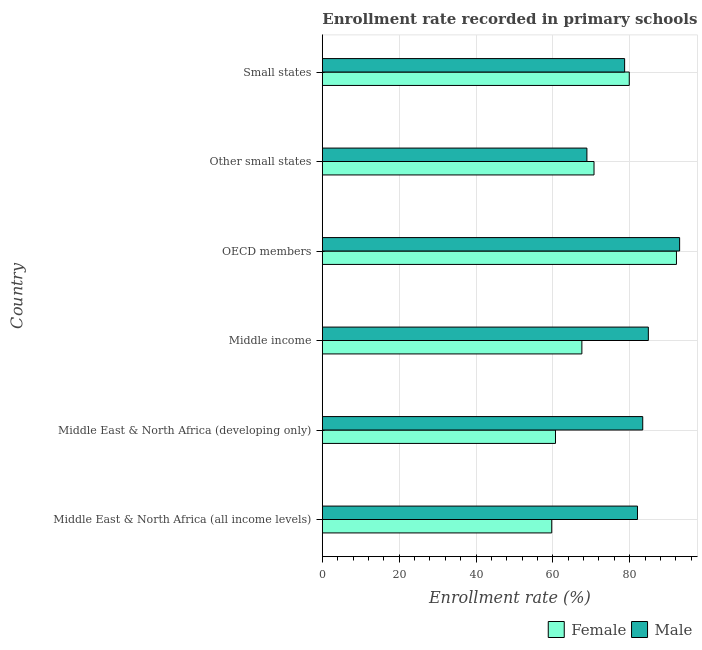How many different coloured bars are there?
Keep it short and to the point. 2. How many bars are there on the 1st tick from the bottom?
Your response must be concise. 2. What is the label of the 3rd group of bars from the top?
Give a very brief answer. OECD members. What is the enrollment rate of male students in Small states?
Your answer should be very brief. 78.69. Across all countries, what is the maximum enrollment rate of female students?
Your answer should be compact. 92.18. Across all countries, what is the minimum enrollment rate of female students?
Give a very brief answer. 59.71. In which country was the enrollment rate of male students maximum?
Give a very brief answer. OECD members. In which country was the enrollment rate of female students minimum?
Provide a succinct answer. Middle East & North Africa (all income levels). What is the total enrollment rate of female students in the graph?
Ensure brevity in your answer.  430.75. What is the difference between the enrollment rate of female students in Middle East & North Africa (all income levels) and that in Middle income?
Make the answer very short. -7.84. What is the difference between the enrollment rate of female students in Small states and the enrollment rate of male students in OECD members?
Make the answer very short. -13.11. What is the average enrollment rate of female students per country?
Provide a succinct answer. 71.79. What is the difference between the enrollment rate of male students and enrollment rate of female students in Middle income?
Your answer should be compact. 17.3. What is the ratio of the enrollment rate of male students in Middle East & North Africa (all income levels) to that in Small states?
Offer a very short reply. 1.04. What is the difference between the highest and the second highest enrollment rate of female students?
Provide a succinct answer. 12.28. What is the difference between the highest and the lowest enrollment rate of female students?
Your response must be concise. 32.46. In how many countries, is the enrollment rate of female students greater than the average enrollment rate of female students taken over all countries?
Your answer should be very brief. 2. Is the sum of the enrollment rate of female students in Middle East & North Africa (all income levels) and Middle East & North Africa (developing only) greater than the maximum enrollment rate of male students across all countries?
Ensure brevity in your answer.  Yes. What does the 1st bar from the top in Other small states represents?
Offer a very short reply. Male. How many countries are there in the graph?
Ensure brevity in your answer.  6. Does the graph contain grids?
Offer a very short reply. Yes. How many legend labels are there?
Provide a succinct answer. 2. What is the title of the graph?
Keep it short and to the point. Enrollment rate recorded in primary schools in year 1979. Does "International Visitors" appear as one of the legend labels in the graph?
Keep it short and to the point. No. What is the label or title of the X-axis?
Provide a succinct answer. Enrollment rate (%). What is the label or title of the Y-axis?
Give a very brief answer. Country. What is the Enrollment rate (%) of Female in Middle East & North Africa (all income levels)?
Provide a succinct answer. 59.71. What is the Enrollment rate (%) in Male in Middle East & North Africa (all income levels)?
Offer a terse response. 82.03. What is the Enrollment rate (%) in Female in Middle East & North Africa (developing only)?
Make the answer very short. 60.69. What is the Enrollment rate (%) in Male in Middle East & North Africa (developing only)?
Your answer should be very brief. 83.4. What is the Enrollment rate (%) of Female in Middle income?
Provide a succinct answer. 67.56. What is the Enrollment rate (%) in Male in Middle income?
Make the answer very short. 84.86. What is the Enrollment rate (%) of Female in OECD members?
Offer a very short reply. 92.18. What is the Enrollment rate (%) of Male in OECD members?
Your answer should be very brief. 93. What is the Enrollment rate (%) in Female in Other small states?
Offer a terse response. 70.72. What is the Enrollment rate (%) of Male in Other small states?
Your response must be concise. 68.87. What is the Enrollment rate (%) in Female in Small states?
Your answer should be compact. 79.89. What is the Enrollment rate (%) of Male in Small states?
Provide a short and direct response. 78.69. Across all countries, what is the maximum Enrollment rate (%) of Female?
Keep it short and to the point. 92.18. Across all countries, what is the maximum Enrollment rate (%) of Male?
Provide a short and direct response. 93. Across all countries, what is the minimum Enrollment rate (%) of Female?
Make the answer very short. 59.71. Across all countries, what is the minimum Enrollment rate (%) in Male?
Your response must be concise. 68.87. What is the total Enrollment rate (%) of Female in the graph?
Your response must be concise. 430.75. What is the total Enrollment rate (%) in Male in the graph?
Make the answer very short. 490.85. What is the difference between the Enrollment rate (%) of Female in Middle East & North Africa (all income levels) and that in Middle East & North Africa (developing only)?
Ensure brevity in your answer.  -0.97. What is the difference between the Enrollment rate (%) in Male in Middle East & North Africa (all income levels) and that in Middle East & North Africa (developing only)?
Offer a very short reply. -1.37. What is the difference between the Enrollment rate (%) of Female in Middle East & North Africa (all income levels) and that in Middle income?
Offer a terse response. -7.84. What is the difference between the Enrollment rate (%) in Male in Middle East & North Africa (all income levels) and that in Middle income?
Provide a succinct answer. -2.83. What is the difference between the Enrollment rate (%) of Female in Middle East & North Africa (all income levels) and that in OECD members?
Your answer should be very brief. -32.46. What is the difference between the Enrollment rate (%) of Male in Middle East & North Africa (all income levels) and that in OECD members?
Make the answer very short. -10.97. What is the difference between the Enrollment rate (%) of Female in Middle East & North Africa (all income levels) and that in Other small states?
Provide a succinct answer. -11.01. What is the difference between the Enrollment rate (%) in Male in Middle East & North Africa (all income levels) and that in Other small states?
Keep it short and to the point. 13.16. What is the difference between the Enrollment rate (%) of Female in Middle East & North Africa (all income levels) and that in Small states?
Your answer should be compact. -20.18. What is the difference between the Enrollment rate (%) in Male in Middle East & North Africa (all income levels) and that in Small states?
Offer a very short reply. 3.35. What is the difference between the Enrollment rate (%) in Female in Middle East & North Africa (developing only) and that in Middle income?
Offer a very short reply. -6.87. What is the difference between the Enrollment rate (%) of Male in Middle East & North Africa (developing only) and that in Middle income?
Offer a terse response. -1.46. What is the difference between the Enrollment rate (%) of Female in Middle East & North Africa (developing only) and that in OECD members?
Give a very brief answer. -31.49. What is the difference between the Enrollment rate (%) of Male in Middle East & North Africa (developing only) and that in OECD members?
Your response must be concise. -9.6. What is the difference between the Enrollment rate (%) in Female in Middle East & North Africa (developing only) and that in Other small states?
Offer a terse response. -10.03. What is the difference between the Enrollment rate (%) in Male in Middle East & North Africa (developing only) and that in Other small states?
Provide a short and direct response. 14.53. What is the difference between the Enrollment rate (%) in Female in Middle East & North Africa (developing only) and that in Small states?
Your response must be concise. -19.21. What is the difference between the Enrollment rate (%) of Male in Middle East & North Africa (developing only) and that in Small states?
Ensure brevity in your answer.  4.71. What is the difference between the Enrollment rate (%) in Female in Middle income and that in OECD members?
Ensure brevity in your answer.  -24.62. What is the difference between the Enrollment rate (%) of Male in Middle income and that in OECD members?
Offer a very short reply. -8.14. What is the difference between the Enrollment rate (%) in Female in Middle income and that in Other small states?
Provide a succinct answer. -3.16. What is the difference between the Enrollment rate (%) of Male in Middle income and that in Other small states?
Keep it short and to the point. 15.99. What is the difference between the Enrollment rate (%) of Female in Middle income and that in Small states?
Your answer should be compact. -12.34. What is the difference between the Enrollment rate (%) in Male in Middle income and that in Small states?
Provide a short and direct response. 6.17. What is the difference between the Enrollment rate (%) in Female in OECD members and that in Other small states?
Make the answer very short. 21.46. What is the difference between the Enrollment rate (%) of Male in OECD members and that in Other small states?
Offer a very short reply. 24.13. What is the difference between the Enrollment rate (%) in Female in OECD members and that in Small states?
Provide a short and direct response. 12.28. What is the difference between the Enrollment rate (%) of Male in OECD members and that in Small states?
Keep it short and to the point. 14.32. What is the difference between the Enrollment rate (%) of Female in Other small states and that in Small states?
Offer a terse response. -9.18. What is the difference between the Enrollment rate (%) in Male in Other small states and that in Small states?
Ensure brevity in your answer.  -9.82. What is the difference between the Enrollment rate (%) of Female in Middle East & North Africa (all income levels) and the Enrollment rate (%) of Male in Middle East & North Africa (developing only)?
Make the answer very short. -23.69. What is the difference between the Enrollment rate (%) of Female in Middle East & North Africa (all income levels) and the Enrollment rate (%) of Male in Middle income?
Your answer should be compact. -25.15. What is the difference between the Enrollment rate (%) of Female in Middle East & North Africa (all income levels) and the Enrollment rate (%) of Male in OECD members?
Your answer should be very brief. -33.29. What is the difference between the Enrollment rate (%) of Female in Middle East & North Africa (all income levels) and the Enrollment rate (%) of Male in Other small states?
Offer a terse response. -9.16. What is the difference between the Enrollment rate (%) in Female in Middle East & North Africa (all income levels) and the Enrollment rate (%) in Male in Small states?
Provide a short and direct response. -18.97. What is the difference between the Enrollment rate (%) of Female in Middle East & North Africa (developing only) and the Enrollment rate (%) of Male in Middle income?
Provide a short and direct response. -24.17. What is the difference between the Enrollment rate (%) of Female in Middle East & North Africa (developing only) and the Enrollment rate (%) of Male in OECD members?
Give a very brief answer. -32.31. What is the difference between the Enrollment rate (%) of Female in Middle East & North Africa (developing only) and the Enrollment rate (%) of Male in Other small states?
Provide a short and direct response. -8.18. What is the difference between the Enrollment rate (%) in Female in Middle East & North Africa (developing only) and the Enrollment rate (%) in Male in Small states?
Your response must be concise. -18. What is the difference between the Enrollment rate (%) in Female in Middle income and the Enrollment rate (%) in Male in OECD members?
Provide a short and direct response. -25.45. What is the difference between the Enrollment rate (%) of Female in Middle income and the Enrollment rate (%) of Male in Other small states?
Provide a succinct answer. -1.31. What is the difference between the Enrollment rate (%) of Female in Middle income and the Enrollment rate (%) of Male in Small states?
Ensure brevity in your answer.  -11.13. What is the difference between the Enrollment rate (%) in Female in OECD members and the Enrollment rate (%) in Male in Other small states?
Your answer should be very brief. 23.31. What is the difference between the Enrollment rate (%) in Female in OECD members and the Enrollment rate (%) in Male in Small states?
Offer a very short reply. 13.49. What is the difference between the Enrollment rate (%) in Female in Other small states and the Enrollment rate (%) in Male in Small states?
Provide a short and direct response. -7.97. What is the average Enrollment rate (%) of Female per country?
Your answer should be very brief. 71.79. What is the average Enrollment rate (%) in Male per country?
Your answer should be very brief. 81.81. What is the difference between the Enrollment rate (%) of Female and Enrollment rate (%) of Male in Middle East & North Africa (all income levels)?
Provide a succinct answer. -22.32. What is the difference between the Enrollment rate (%) of Female and Enrollment rate (%) of Male in Middle East & North Africa (developing only)?
Offer a very short reply. -22.71. What is the difference between the Enrollment rate (%) of Female and Enrollment rate (%) of Male in Middle income?
Keep it short and to the point. -17.3. What is the difference between the Enrollment rate (%) of Female and Enrollment rate (%) of Male in OECD members?
Offer a very short reply. -0.83. What is the difference between the Enrollment rate (%) of Female and Enrollment rate (%) of Male in Other small states?
Your answer should be very brief. 1.85. What is the difference between the Enrollment rate (%) in Female and Enrollment rate (%) in Male in Small states?
Your answer should be compact. 1.21. What is the ratio of the Enrollment rate (%) in Female in Middle East & North Africa (all income levels) to that in Middle East & North Africa (developing only)?
Offer a terse response. 0.98. What is the ratio of the Enrollment rate (%) of Male in Middle East & North Africa (all income levels) to that in Middle East & North Africa (developing only)?
Provide a short and direct response. 0.98. What is the ratio of the Enrollment rate (%) in Female in Middle East & North Africa (all income levels) to that in Middle income?
Your response must be concise. 0.88. What is the ratio of the Enrollment rate (%) of Male in Middle East & North Africa (all income levels) to that in Middle income?
Your answer should be compact. 0.97. What is the ratio of the Enrollment rate (%) of Female in Middle East & North Africa (all income levels) to that in OECD members?
Keep it short and to the point. 0.65. What is the ratio of the Enrollment rate (%) in Male in Middle East & North Africa (all income levels) to that in OECD members?
Your response must be concise. 0.88. What is the ratio of the Enrollment rate (%) in Female in Middle East & North Africa (all income levels) to that in Other small states?
Make the answer very short. 0.84. What is the ratio of the Enrollment rate (%) in Male in Middle East & North Africa (all income levels) to that in Other small states?
Keep it short and to the point. 1.19. What is the ratio of the Enrollment rate (%) of Female in Middle East & North Africa (all income levels) to that in Small states?
Provide a succinct answer. 0.75. What is the ratio of the Enrollment rate (%) in Male in Middle East & North Africa (all income levels) to that in Small states?
Offer a terse response. 1.04. What is the ratio of the Enrollment rate (%) in Female in Middle East & North Africa (developing only) to that in Middle income?
Provide a succinct answer. 0.9. What is the ratio of the Enrollment rate (%) in Male in Middle East & North Africa (developing only) to that in Middle income?
Offer a terse response. 0.98. What is the ratio of the Enrollment rate (%) in Female in Middle East & North Africa (developing only) to that in OECD members?
Offer a terse response. 0.66. What is the ratio of the Enrollment rate (%) of Male in Middle East & North Africa (developing only) to that in OECD members?
Your answer should be compact. 0.9. What is the ratio of the Enrollment rate (%) in Female in Middle East & North Africa (developing only) to that in Other small states?
Give a very brief answer. 0.86. What is the ratio of the Enrollment rate (%) of Male in Middle East & North Africa (developing only) to that in Other small states?
Provide a succinct answer. 1.21. What is the ratio of the Enrollment rate (%) of Female in Middle East & North Africa (developing only) to that in Small states?
Your answer should be very brief. 0.76. What is the ratio of the Enrollment rate (%) in Male in Middle East & North Africa (developing only) to that in Small states?
Your answer should be very brief. 1.06. What is the ratio of the Enrollment rate (%) in Female in Middle income to that in OECD members?
Your answer should be very brief. 0.73. What is the ratio of the Enrollment rate (%) in Male in Middle income to that in OECD members?
Offer a very short reply. 0.91. What is the ratio of the Enrollment rate (%) of Female in Middle income to that in Other small states?
Give a very brief answer. 0.96. What is the ratio of the Enrollment rate (%) of Male in Middle income to that in Other small states?
Offer a terse response. 1.23. What is the ratio of the Enrollment rate (%) in Female in Middle income to that in Small states?
Give a very brief answer. 0.85. What is the ratio of the Enrollment rate (%) of Male in Middle income to that in Small states?
Keep it short and to the point. 1.08. What is the ratio of the Enrollment rate (%) of Female in OECD members to that in Other small states?
Your response must be concise. 1.3. What is the ratio of the Enrollment rate (%) in Male in OECD members to that in Other small states?
Your answer should be very brief. 1.35. What is the ratio of the Enrollment rate (%) of Female in OECD members to that in Small states?
Your answer should be compact. 1.15. What is the ratio of the Enrollment rate (%) of Male in OECD members to that in Small states?
Keep it short and to the point. 1.18. What is the ratio of the Enrollment rate (%) in Female in Other small states to that in Small states?
Make the answer very short. 0.89. What is the ratio of the Enrollment rate (%) of Male in Other small states to that in Small states?
Your response must be concise. 0.88. What is the difference between the highest and the second highest Enrollment rate (%) in Female?
Offer a very short reply. 12.28. What is the difference between the highest and the second highest Enrollment rate (%) in Male?
Provide a short and direct response. 8.14. What is the difference between the highest and the lowest Enrollment rate (%) in Female?
Your answer should be very brief. 32.46. What is the difference between the highest and the lowest Enrollment rate (%) of Male?
Make the answer very short. 24.13. 